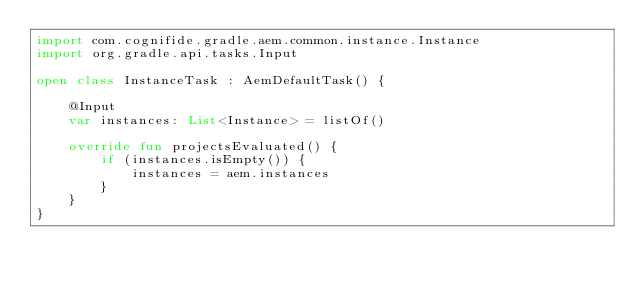Convert code to text. <code><loc_0><loc_0><loc_500><loc_500><_Kotlin_>import com.cognifide.gradle.aem.common.instance.Instance
import org.gradle.api.tasks.Input

open class InstanceTask : AemDefaultTask() {

    @Input
    var instances: List<Instance> = listOf()

    override fun projectsEvaluated() {
        if (instances.isEmpty()) {
            instances = aem.instances
        }
    }
}
</code> 